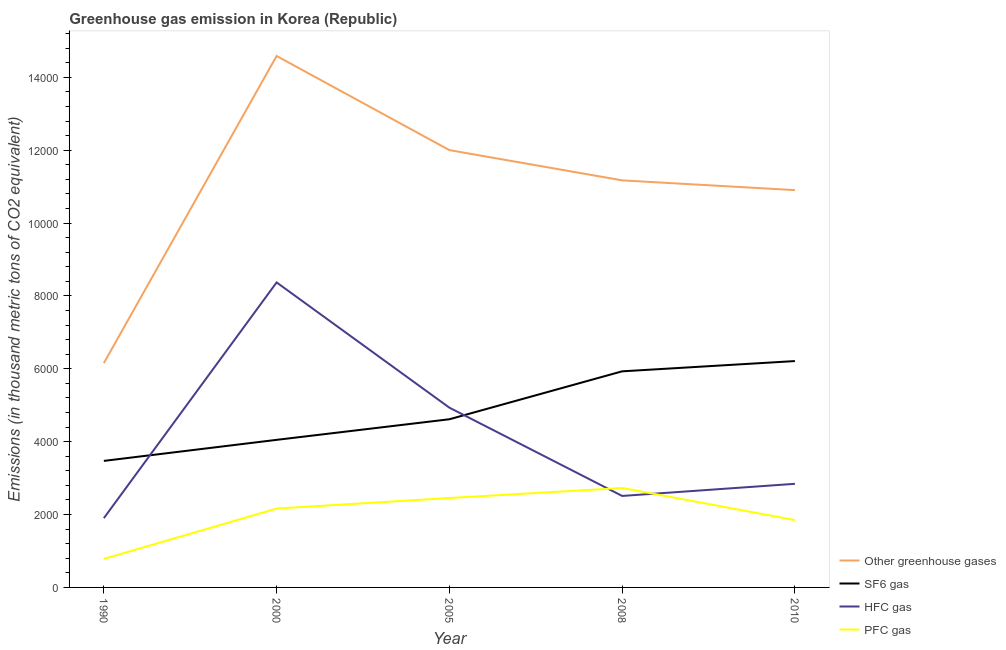Does the line corresponding to emission of pfc gas intersect with the line corresponding to emission of greenhouse gases?
Provide a short and direct response. No. Is the number of lines equal to the number of legend labels?
Offer a terse response. Yes. What is the emission of pfc gas in 2010?
Make the answer very short. 1848. Across all years, what is the maximum emission of sf6 gas?
Offer a very short reply. 6213. Across all years, what is the minimum emission of pfc gas?
Offer a terse response. 782.6. What is the total emission of hfc gas in the graph?
Provide a succinct answer. 2.06e+04. What is the difference between the emission of sf6 gas in 1990 and that in 2010?
Provide a succinct answer. -2740.1. What is the difference between the emission of pfc gas in 2000 and the emission of greenhouse gases in 2010?
Ensure brevity in your answer.  -8740.1. What is the average emission of sf6 gas per year?
Provide a succinct answer. 4856.74. In the year 2005, what is the difference between the emission of sf6 gas and emission of greenhouse gases?
Make the answer very short. -7387.6. What is the ratio of the emission of sf6 gas in 2000 to that in 2010?
Your response must be concise. 0.65. What is the difference between the highest and the second highest emission of greenhouse gases?
Offer a terse response. 2584. What is the difference between the highest and the lowest emission of hfc gas?
Provide a succinct answer. 6470.2. In how many years, is the emission of sf6 gas greater than the average emission of sf6 gas taken over all years?
Provide a succinct answer. 2. Is the sum of the emission of pfc gas in 2005 and 2010 greater than the maximum emission of hfc gas across all years?
Ensure brevity in your answer.  No. Is it the case that in every year, the sum of the emission of greenhouse gases and emission of sf6 gas is greater than the emission of hfc gas?
Offer a terse response. Yes. Does the emission of greenhouse gases monotonically increase over the years?
Keep it short and to the point. No. Is the emission of pfc gas strictly greater than the emission of hfc gas over the years?
Your answer should be compact. No. Is the emission of hfc gas strictly less than the emission of greenhouse gases over the years?
Offer a very short reply. Yes. How many lines are there?
Your response must be concise. 4. How many years are there in the graph?
Keep it short and to the point. 5. What is the difference between two consecutive major ticks on the Y-axis?
Offer a terse response. 2000. Does the graph contain any zero values?
Your response must be concise. No. Does the graph contain grids?
Provide a succinct answer. No. How many legend labels are there?
Make the answer very short. 4. How are the legend labels stacked?
Your answer should be very brief. Vertical. What is the title of the graph?
Your response must be concise. Greenhouse gas emission in Korea (Republic). What is the label or title of the Y-axis?
Offer a very short reply. Emissions (in thousand metric tons of CO2 equivalent). What is the Emissions (in thousand metric tons of CO2 equivalent) in Other greenhouse gases in 1990?
Offer a very short reply. 6157.2. What is the Emissions (in thousand metric tons of CO2 equivalent) of SF6 gas in 1990?
Ensure brevity in your answer.  3472.9. What is the Emissions (in thousand metric tons of CO2 equivalent) in HFC gas in 1990?
Offer a very short reply. 1901.7. What is the Emissions (in thousand metric tons of CO2 equivalent) of PFC gas in 1990?
Your answer should be very brief. 782.6. What is the Emissions (in thousand metric tons of CO2 equivalent) of Other greenhouse gases in 2000?
Keep it short and to the point. 1.46e+04. What is the Emissions (in thousand metric tons of CO2 equivalent) of SF6 gas in 2000?
Your answer should be compact. 4050.5. What is the Emissions (in thousand metric tons of CO2 equivalent) in HFC gas in 2000?
Keep it short and to the point. 8371.9. What is the Emissions (in thousand metric tons of CO2 equivalent) of PFC gas in 2000?
Provide a succinct answer. 2164.9. What is the Emissions (in thousand metric tons of CO2 equivalent) of Other greenhouse gases in 2005?
Offer a terse response. 1.20e+04. What is the Emissions (in thousand metric tons of CO2 equivalent) of SF6 gas in 2005?
Provide a succinct answer. 4615.7. What is the Emissions (in thousand metric tons of CO2 equivalent) in HFC gas in 2005?
Your response must be concise. 4933.9. What is the Emissions (in thousand metric tons of CO2 equivalent) of PFC gas in 2005?
Keep it short and to the point. 2453.7. What is the Emissions (in thousand metric tons of CO2 equivalent) in Other greenhouse gases in 2008?
Your answer should be compact. 1.12e+04. What is the Emissions (in thousand metric tons of CO2 equivalent) in SF6 gas in 2008?
Provide a short and direct response. 5931.6. What is the Emissions (in thousand metric tons of CO2 equivalent) in HFC gas in 2008?
Offer a very short reply. 2511.2. What is the Emissions (in thousand metric tons of CO2 equivalent) in PFC gas in 2008?
Ensure brevity in your answer.  2730.1. What is the Emissions (in thousand metric tons of CO2 equivalent) in Other greenhouse gases in 2010?
Offer a very short reply. 1.09e+04. What is the Emissions (in thousand metric tons of CO2 equivalent) in SF6 gas in 2010?
Offer a very short reply. 6213. What is the Emissions (in thousand metric tons of CO2 equivalent) of HFC gas in 2010?
Offer a terse response. 2844. What is the Emissions (in thousand metric tons of CO2 equivalent) of PFC gas in 2010?
Offer a very short reply. 1848. Across all years, what is the maximum Emissions (in thousand metric tons of CO2 equivalent) in Other greenhouse gases?
Provide a short and direct response. 1.46e+04. Across all years, what is the maximum Emissions (in thousand metric tons of CO2 equivalent) of SF6 gas?
Your answer should be compact. 6213. Across all years, what is the maximum Emissions (in thousand metric tons of CO2 equivalent) of HFC gas?
Give a very brief answer. 8371.9. Across all years, what is the maximum Emissions (in thousand metric tons of CO2 equivalent) of PFC gas?
Your answer should be very brief. 2730.1. Across all years, what is the minimum Emissions (in thousand metric tons of CO2 equivalent) in Other greenhouse gases?
Your answer should be compact. 6157.2. Across all years, what is the minimum Emissions (in thousand metric tons of CO2 equivalent) of SF6 gas?
Offer a very short reply. 3472.9. Across all years, what is the minimum Emissions (in thousand metric tons of CO2 equivalent) in HFC gas?
Offer a terse response. 1901.7. Across all years, what is the minimum Emissions (in thousand metric tons of CO2 equivalent) in PFC gas?
Offer a very short reply. 782.6. What is the total Emissions (in thousand metric tons of CO2 equivalent) of Other greenhouse gases in the graph?
Offer a terse response. 5.48e+04. What is the total Emissions (in thousand metric tons of CO2 equivalent) in SF6 gas in the graph?
Provide a short and direct response. 2.43e+04. What is the total Emissions (in thousand metric tons of CO2 equivalent) in HFC gas in the graph?
Give a very brief answer. 2.06e+04. What is the total Emissions (in thousand metric tons of CO2 equivalent) of PFC gas in the graph?
Your answer should be very brief. 9979.3. What is the difference between the Emissions (in thousand metric tons of CO2 equivalent) of Other greenhouse gases in 1990 and that in 2000?
Keep it short and to the point. -8430.1. What is the difference between the Emissions (in thousand metric tons of CO2 equivalent) in SF6 gas in 1990 and that in 2000?
Your answer should be compact. -577.6. What is the difference between the Emissions (in thousand metric tons of CO2 equivalent) in HFC gas in 1990 and that in 2000?
Your response must be concise. -6470.2. What is the difference between the Emissions (in thousand metric tons of CO2 equivalent) in PFC gas in 1990 and that in 2000?
Offer a terse response. -1382.3. What is the difference between the Emissions (in thousand metric tons of CO2 equivalent) in Other greenhouse gases in 1990 and that in 2005?
Your response must be concise. -5846.1. What is the difference between the Emissions (in thousand metric tons of CO2 equivalent) of SF6 gas in 1990 and that in 2005?
Give a very brief answer. -1142.8. What is the difference between the Emissions (in thousand metric tons of CO2 equivalent) in HFC gas in 1990 and that in 2005?
Offer a terse response. -3032.2. What is the difference between the Emissions (in thousand metric tons of CO2 equivalent) in PFC gas in 1990 and that in 2005?
Provide a succinct answer. -1671.1. What is the difference between the Emissions (in thousand metric tons of CO2 equivalent) of Other greenhouse gases in 1990 and that in 2008?
Your answer should be compact. -5015.7. What is the difference between the Emissions (in thousand metric tons of CO2 equivalent) in SF6 gas in 1990 and that in 2008?
Your response must be concise. -2458.7. What is the difference between the Emissions (in thousand metric tons of CO2 equivalent) in HFC gas in 1990 and that in 2008?
Provide a succinct answer. -609.5. What is the difference between the Emissions (in thousand metric tons of CO2 equivalent) of PFC gas in 1990 and that in 2008?
Provide a succinct answer. -1947.5. What is the difference between the Emissions (in thousand metric tons of CO2 equivalent) of Other greenhouse gases in 1990 and that in 2010?
Offer a very short reply. -4747.8. What is the difference between the Emissions (in thousand metric tons of CO2 equivalent) in SF6 gas in 1990 and that in 2010?
Make the answer very short. -2740.1. What is the difference between the Emissions (in thousand metric tons of CO2 equivalent) in HFC gas in 1990 and that in 2010?
Your answer should be very brief. -942.3. What is the difference between the Emissions (in thousand metric tons of CO2 equivalent) of PFC gas in 1990 and that in 2010?
Offer a terse response. -1065.4. What is the difference between the Emissions (in thousand metric tons of CO2 equivalent) in Other greenhouse gases in 2000 and that in 2005?
Offer a very short reply. 2584. What is the difference between the Emissions (in thousand metric tons of CO2 equivalent) in SF6 gas in 2000 and that in 2005?
Offer a very short reply. -565.2. What is the difference between the Emissions (in thousand metric tons of CO2 equivalent) of HFC gas in 2000 and that in 2005?
Ensure brevity in your answer.  3438. What is the difference between the Emissions (in thousand metric tons of CO2 equivalent) in PFC gas in 2000 and that in 2005?
Your response must be concise. -288.8. What is the difference between the Emissions (in thousand metric tons of CO2 equivalent) of Other greenhouse gases in 2000 and that in 2008?
Offer a very short reply. 3414.4. What is the difference between the Emissions (in thousand metric tons of CO2 equivalent) of SF6 gas in 2000 and that in 2008?
Ensure brevity in your answer.  -1881.1. What is the difference between the Emissions (in thousand metric tons of CO2 equivalent) in HFC gas in 2000 and that in 2008?
Make the answer very short. 5860.7. What is the difference between the Emissions (in thousand metric tons of CO2 equivalent) in PFC gas in 2000 and that in 2008?
Your answer should be very brief. -565.2. What is the difference between the Emissions (in thousand metric tons of CO2 equivalent) in Other greenhouse gases in 2000 and that in 2010?
Offer a terse response. 3682.3. What is the difference between the Emissions (in thousand metric tons of CO2 equivalent) in SF6 gas in 2000 and that in 2010?
Your answer should be compact. -2162.5. What is the difference between the Emissions (in thousand metric tons of CO2 equivalent) of HFC gas in 2000 and that in 2010?
Keep it short and to the point. 5527.9. What is the difference between the Emissions (in thousand metric tons of CO2 equivalent) in PFC gas in 2000 and that in 2010?
Your response must be concise. 316.9. What is the difference between the Emissions (in thousand metric tons of CO2 equivalent) in Other greenhouse gases in 2005 and that in 2008?
Ensure brevity in your answer.  830.4. What is the difference between the Emissions (in thousand metric tons of CO2 equivalent) in SF6 gas in 2005 and that in 2008?
Provide a succinct answer. -1315.9. What is the difference between the Emissions (in thousand metric tons of CO2 equivalent) of HFC gas in 2005 and that in 2008?
Your answer should be very brief. 2422.7. What is the difference between the Emissions (in thousand metric tons of CO2 equivalent) in PFC gas in 2005 and that in 2008?
Provide a succinct answer. -276.4. What is the difference between the Emissions (in thousand metric tons of CO2 equivalent) in Other greenhouse gases in 2005 and that in 2010?
Provide a succinct answer. 1098.3. What is the difference between the Emissions (in thousand metric tons of CO2 equivalent) in SF6 gas in 2005 and that in 2010?
Offer a terse response. -1597.3. What is the difference between the Emissions (in thousand metric tons of CO2 equivalent) in HFC gas in 2005 and that in 2010?
Your answer should be compact. 2089.9. What is the difference between the Emissions (in thousand metric tons of CO2 equivalent) in PFC gas in 2005 and that in 2010?
Keep it short and to the point. 605.7. What is the difference between the Emissions (in thousand metric tons of CO2 equivalent) in Other greenhouse gases in 2008 and that in 2010?
Give a very brief answer. 267.9. What is the difference between the Emissions (in thousand metric tons of CO2 equivalent) in SF6 gas in 2008 and that in 2010?
Your response must be concise. -281.4. What is the difference between the Emissions (in thousand metric tons of CO2 equivalent) in HFC gas in 2008 and that in 2010?
Give a very brief answer. -332.8. What is the difference between the Emissions (in thousand metric tons of CO2 equivalent) in PFC gas in 2008 and that in 2010?
Make the answer very short. 882.1. What is the difference between the Emissions (in thousand metric tons of CO2 equivalent) in Other greenhouse gases in 1990 and the Emissions (in thousand metric tons of CO2 equivalent) in SF6 gas in 2000?
Offer a very short reply. 2106.7. What is the difference between the Emissions (in thousand metric tons of CO2 equivalent) of Other greenhouse gases in 1990 and the Emissions (in thousand metric tons of CO2 equivalent) of HFC gas in 2000?
Make the answer very short. -2214.7. What is the difference between the Emissions (in thousand metric tons of CO2 equivalent) in Other greenhouse gases in 1990 and the Emissions (in thousand metric tons of CO2 equivalent) in PFC gas in 2000?
Provide a succinct answer. 3992.3. What is the difference between the Emissions (in thousand metric tons of CO2 equivalent) of SF6 gas in 1990 and the Emissions (in thousand metric tons of CO2 equivalent) of HFC gas in 2000?
Provide a short and direct response. -4899. What is the difference between the Emissions (in thousand metric tons of CO2 equivalent) in SF6 gas in 1990 and the Emissions (in thousand metric tons of CO2 equivalent) in PFC gas in 2000?
Keep it short and to the point. 1308. What is the difference between the Emissions (in thousand metric tons of CO2 equivalent) of HFC gas in 1990 and the Emissions (in thousand metric tons of CO2 equivalent) of PFC gas in 2000?
Provide a short and direct response. -263.2. What is the difference between the Emissions (in thousand metric tons of CO2 equivalent) in Other greenhouse gases in 1990 and the Emissions (in thousand metric tons of CO2 equivalent) in SF6 gas in 2005?
Offer a very short reply. 1541.5. What is the difference between the Emissions (in thousand metric tons of CO2 equivalent) in Other greenhouse gases in 1990 and the Emissions (in thousand metric tons of CO2 equivalent) in HFC gas in 2005?
Keep it short and to the point. 1223.3. What is the difference between the Emissions (in thousand metric tons of CO2 equivalent) of Other greenhouse gases in 1990 and the Emissions (in thousand metric tons of CO2 equivalent) of PFC gas in 2005?
Ensure brevity in your answer.  3703.5. What is the difference between the Emissions (in thousand metric tons of CO2 equivalent) in SF6 gas in 1990 and the Emissions (in thousand metric tons of CO2 equivalent) in HFC gas in 2005?
Give a very brief answer. -1461. What is the difference between the Emissions (in thousand metric tons of CO2 equivalent) in SF6 gas in 1990 and the Emissions (in thousand metric tons of CO2 equivalent) in PFC gas in 2005?
Your answer should be very brief. 1019.2. What is the difference between the Emissions (in thousand metric tons of CO2 equivalent) in HFC gas in 1990 and the Emissions (in thousand metric tons of CO2 equivalent) in PFC gas in 2005?
Provide a short and direct response. -552. What is the difference between the Emissions (in thousand metric tons of CO2 equivalent) of Other greenhouse gases in 1990 and the Emissions (in thousand metric tons of CO2 equivalent) of SF6 gas in 2008?
Offer a terse response. 225.6. What is the difference between the Emissions (in thousand metric tons of CO2 equivalent) in Other greenhouse gases in 1990 and the Emissions (in thousand metric tons of CO2 equivalent) in HFC gas in 2008?
Ensure brevity in your answer.  3646. What is the difference between the Emissions (in thousand metric tons of CO2 equivalent) of Other greenhouse gases in 1990 and the Emissions (in thousand metric tons of CO2 equivalent) of PFC gas in 2008?
Your answer should be very brief. 3427.1. What is the difference between the Emissions (in thousand metric tons of CO2 equivalent) in SF6 gas in 1990 and the Emissions (in thousand metric tons of CO2 equivalent) in HFC gas in 2008?
Your answer should be compact. 961.7. What is the difference between the Emissions (in thousand metric tons of CO2 equivalent) of SF6 gas in 1990 and the Emissions (in thousand metric tons of CO2 equivalent) of PFC gas in 2008?
Offer a terse response. 742.8. What is the difference between the Emissions (in thousand metric tons of CO2 equivalent) in HFC gas in 1990 and the Emissions (in thousand metric tons of CO2 equivalent) in PFC gas in 2008?
Make the answer very short. -828.4. What is the difference between the Emissions (in thousand metric tons of CO2 equivalent) of Other greenhouse gases in 1990 and the Emissions (in thousand metric tons of CO2 equivalent) of SF6 gas in 2010?
Offer a terse response. -55.8. What is the difference between the Emissions (in thousand metric tons of CO2 equivalent) in Other greenhouse gases in 1990 and the Emissions (in thousand metric tons of CO2 equivalent) in HFC gas in 2010?
Ensure brevity in your answer.  3313.2. What is the difference between the Emissions (in thousand metric tons of CO2 equivalent) of Other greenhouse gases in 1990 and the Emissions (in thousand metric tons of CO2 equivalent) of PFC gas in 2010?
Offer a terse response. 4309.2. What is the difference between the Emissions (in thousand metric tons of CO2 equivalent) in SF6 gas in 1990 and the Emissions (in thousand metric tons of CO2 equivalent) in HFC gas in 2010?
Your response must be concise. 628.9. What is the difference between the Emissions (in thousand metric tons of CO2 equivalent) of SF6 gas in 1990 and the Emissions (in thousand metric tons of CO2 equivalent) of PFC gas in 2010?
Offer a very short reply. 1624.9. What is the difference between the Emissions (in thousand metric tons of CO2 equivalent) in HFC gas in 1990 and the Emissions (in thousand metric tons of CO2 equivalent) in PFC gas in 2010?
Provide a short and direct response. 53.7. What is the difference between the Emissions (in thousand metric tons of CO2 equivalent) in Other greenhouse gases in 2000 and the Emissions (in thousand metric tons of CO2 equivalent) in SF6 gas in 2005?
Make the answer very short. 9971.6. What is the difference between the Emissions (in thousand metric tons of CO2 equivalent) in Other greenhouse gases in 2000 and the Emissions (in thousand metric tons of CO2 equivalent) in HFC gas in 2005?
Your response must be concise. 9653.4. What is the difference between the Emissions (in thousand metric tons of CO2 equivalent) of Other greenhouse gases in 2000 and the Emissions (in thousand metric tons of CO2 equivalent) of PFC gas in 2005?
Provide a short and direct response. 1.21e+04. What is the difference between the Emissions (in thousand metric tons of CO2 equivalent) in SF6 gas in 2000 and the Emissions (in thousand metric tons of CO2 equivalent) in HFC gas in 2005?
Your answer should be compact. -883.4. What is the difference between the Emissions (in thousand metric tons of CO2 equivalent) of SF6 gas in 2000 and the Emissions (in thousand metric tons of CO2 equivalent) of PFC gas in 2005?
Offer a very short reply. 1596.8. What is the difference between the Emissions (in thousand metric tons of CO2 equivalent) of HFC gas in 2000 and the Emissions (in thousand metric tons of CO2 equivalent) of PFC gas in 2005?
Your answer should be compact. 5918.2. What is the difference between the Emissions (in thousand metric tons of CO2 equivalent) of Other greenhouse gases in 2000 and the Emissions (in thousand metric tons of CO2 equivalent) of SF6 gas in 2008?
Provide a succinct answer. 8655.7. What is the difference between the Emissions (in thousand metric tons of CO2 equivalent) in Other greenhouse gases in 2000 and the Emissions (in thousand metric tons of CO2 equivalent) in HFC gas in 2008?
Ensure brevity in your answer.  1.21e+04. What is the difference between the Emissions (in thousand metric tons of CO2 equivalent) in Other greenhouse gases in 2000 and the Emissions (in thousand metric tons of CO2 equivalent) in PFC gas in 2008?
Provide a succinct answer. 1.19e+04. What is the difference between the Emissions (in thousand metric tons of CO2 equivalent) of SF6 gas in 2000 and the Emissions (in thousand metric tons of CO2 equivalent) of HFC gas in 2008?
Give a very brief answer. 1539.3. What is the difference between the Emissions (in thousand metric tons of CO2 equivalent) of SF6 gas in 2000 and the Emissions (in thousand metric tons of CO2 equivalent) of PFC gas in 2008?
Provide a succinct answer. 1320.4. What is the difference between the Emissions (in thousand metric tons of CO2 equivalent) in HFC gas in 2000 and the Emissions (in thousand metric tons of CO2 equivalent) in PFC gas in 2008?
Offer a very short reply. 5641.8. What is the difference between the Emissions (in thousand metric tons of CO2 equivalent) of Other greenhouse gases in 2000 and the Emissions (in thousand metric tons of CO2 equivalent) of SF6 gas in 2010?
Keep it short and to the point. 8374.3. What is the difference between the Emissions (in thousand metric tons of CO2 equivalent) of Other greenhouse gases in 2000 and the Emissions (in thousand metric tons of CO2 equivalent) of HFC gas in 2010?
Give a very brief answer. 1.17e+04. What is the difference between the Emissions (in thousand metric tons of CO2 equivalent) of Other greenhouse gases in 2000 and the Emissions (in thousand metric tons of CO2 equivalent) of PFC gas in 2010?
Offer a very short reply. 1.27e+04. What is the difference between the Emissions (in thousand metric tons of CO2 equivalent) of SF6 gas in 2000 and the Emissions (in thousand metric tons of CO2 equivalent) of HFC gas in 2010?
Offer a very short reply. 1206.5. What is the difference between the Emissions (in thousand metric tons of CO2 equivalent) of SF6 gas in 2000 and the Emissions (in thousand metric tons of CO2 equivalent) of PFC gas in 2010?
Your response must be concise. 2202.5. What is the difference between the Emissions (in thousand metric tons of CO2 equivalent) in HFC gas in 2000 and the Emissions (in thousand metric tons of CO2 equivalent) in PFC gas in 2010?
Offer a very short reply. 6523.9. What is the difference between the Emissions (in thousand metric tons of CO2 equivalent) in Other greenhouse gases in 2005 and the Emissions (in thousand metric tons of CO2 equivalent) in SF6 gas in 2008?
Ensure brevity in your answer.  6071.7. What is the difference between the Emissions (in thousand metric tons of CO2 equivalent) of Other greenhouse gases in 2005 and the Emissions (in thousand metric tons of CO2 equivalent) of HFC gas in 2008?
Keep it short and to the point. 9492.1. What is the difference between the Emissions (in thousand metric tons of CO2 equivalent) of Other greenhouse gases in 2005 and the Emissions (in thousand metric tons of CO2 equivalent) of PFC gas in 2008?
Offer a very short reply. 9273.2. What is the difference between the Emissions (in thousand metric tons of CO2 equivalent) of SF6 gas in 2005 and the Emissions (in thousand metric tons of CO2 equivalent) of HFC gas in 2008?
Ensure brevity in your answer.  2104.5. What is the difference between the Emissions (in thousand metric tons of CO2 equivalent) of SF6 gas in 2005 and the Emissions (in thousand metric tons of CO2 equivalent) of PFC gas in 2008?
Offer a terse response. 1885.6. What is the difference between the Emissions (in thousand metric tons of CO2 equivalent) of HFC gas in 2005 and the Emissions (in thousand metric tons of CO2 equivalent) of PFC gas in 2008?
Give a very brief answer. 2203.8. What is the difference between the Emissions (in thousand metric tons of CO2 equivalent) of Other greenhouse gases in 2005 and the Emissions (in thousand metric tons of CO2 equivalent) of SF6 gas in 2010?
Offer a terse response. 5790.3. What is the difference between the Emissions (in thousand metric tons of CO2 equivalent) of Other greenhouse gases in 2005 and the Emissions (in thousand metric tons of CO2 equivalent) of HFC gas in 2010?
Provide a succinct answer. 9159.3. What is the difference between the Emissions (in thousand metric tons of CO2 equivalent) in Other greenhouse gases in 2005 and the Emissions (in thousand metric tons of CO2 equivalent) in PFC gas in 2010?
Your response must be concise. 1.02e+04. What is the difference between the Emissions (in thousand metric tons of CO2 equivalent) in SF6 gas in 2005 and the Emissions (in thousand metric tons of CO2 equivalent) in HFC gas in 2010?
Ensure brevity in your answer.  1771.7. What is the difference between the Emissions (in thousand metric tons of CO2 equivalent) in SF6 gas in 2005 and the Emissions (in thousand metric tons of CO2 equivalent) in PFC gas in 2010?
Ensure brevity in your answer.  2767.7. What is the difference between the Emissions (in thousand metric tons of CO2 equivalent) of HFC gas in 2005 and the Emissions (in thousand metric tons of CO2 equivalent) of PFC gas in 2010?
Ensure brevity in your answer.  3085.9. What is the difference between the Emissions (in thousand metric tons of CO2 equivalent) in Other greenhouse gases in 2008 and the Emissions (in thousand metric tons of CO2 equivalent) in SF6 gas in 2010?
Offer a terse response. 4959.9. What is the difference between the Emissions (in thousand metric tons of CO2 equivalent) of Other greenhouse gases in 2008 and the Emissions (in thousand metric tons of CO2 equivalent) of HFC gas in 2010?
Your answer should be compact. 8328.9. What is the difference between the Emissions (in thousand metric tons of CO2 equivalent) of Other greenhouse gases in 2008 and the Emissions (in thousand metric tons of CO2 equivalent) of PFC gas in 2010?
Provide a succinct answer. 9324.9. What is the difference between the Emissions (in thousand metric tons of CO2 equivalent) of SF6 gas in 2008 and the Emissions (in thousand metric tons of CO2 equivalent) of HFC gas in 2010?
Provide a short and direct response. 3087.6. What is the difference between the Emissions (in thousand metric tons of CO2 equivalent) of SF6 gas in 2008 and the Emissions (in thousand metric tons of CO2 equivalent) of PFC gas in 2010?
Offer a terse response. 4083.6. What is the difference between the Emissions (in thousand metric tons of CO2 equivalent) of HFC gas in 2008 and the Emissions (in thousand metric tons of CO2 equivalent) of PFC gas in 2010?
Your answer should be very brief. 663.2. What is the average Emissions (in thousand metric tons of CO2 equivalent) of Other greenhouse gases per year?
Ensure brevity in your answer.  1.10e+04. What is the average Emissions (in thousand metric tons of CO2 equivalent) of SF6 gas per year?
Ensure brevity in your answer.  4856.74. What is the average Emissions (in thousand metric tons of CO2 equivalent) in HFC gas per year?
Provide a succinct answer. 4112.54. What is the average Emissions (in thousand metric tons of CO2 equivalent) in PFC gas per year?
Ensure brevity in your answer.  1995.86. In the year 1990, what is the difference between the Emissions (in thousand metric tons of CO2 equivalent) of Other greenhouse gases and Emissions (in thousand metric tons of CO2 equivalent) of SF6 gas?
Make the answer very short. 2684.3. In the year 1990, what is the difference between the Emissions (in thousand metric tons of CO2 equivalent) in Other greenhouse gases and Emissions (in thousand metric tons of CO2 equivalent) in HFC gas?
Offer a terse response. 4255.5. In the year 1990, what is the difference between the Emissions (in thousand metric tons of CO2 equivalent) in Other greenhouse gases and Emissions (in thousand metric tons of CO2 equivalent) in PFC gas?
Provide a short and direct response. 5374.6. In the year 1990, what is the difference between the Emissions (in thousand metric tons of CO2 equivalent) of SF6 gas and Emissions (in thousand metric tons of CO2 equivalent) of HFC gas?
Your response must be concise. 1571.2. In the year 1990, what is the difference between the Emissions (in thousand metric tons of CO2 equivalent) of SF6 gas and Emissions (in thousand metric tons of CO2 equivalent) of PFC gas?
Make the answer very short. 2690.3. In the year 1990, what is the difference between the Emissions (in thousand metric tons of CO2 equivalent) in HFC gas and Emissions (in thousand metric tons of CO2 equivalent) in PFC gas?
Your answer should be very brief. 1119.1. In the year 2000, what is the difference between the Emissions (in thousand metric tons of CO2 equivalent) in Other greenhouse gases and Emissions (in thousand metric tons of CO2 equivalent) in SF6 gas?
Provide a succinct answer. 1.05e+04. In the year 2000, what is the difference between the Emissions (in thousand metric tons of CO2 equivalent) of Other greenhouse gases and Emissions (in thousand metric tons of CO2 equivalent) of HFC gas?
Make the answer very short. 6215.4. In the year 2000, what is the difference between the Emissions (in thousand metric tons of CO2 equivalent) in Other greenhouse gases and Emissions (in thousand metric tons of CO2 equivalent) in PFC gas?
Keep it short and to the point. 1.24e+04. In the year 2000, what is the difference between the Emissions (in thousand metric tons of CO2 equivalent) in SF6 gas and Emissions (in thousand metric tons of CO2 equivalent) in HFC gas?
Your answer should be very brief. -4321.4. In the year 2000, what is the difference between the Emissions (in thousand metric tons of CO2 equivalent) in SF6 gas and Emissions (in thousand metric tons of CO2 equivalent) in PFC gas?
Your answer should be very brief. 1885.6. In the year 2000, what is the difference between the Emissions (in thousand metric tons of CO2 equivalent) of HFC gas and Emissions (in thousand metric tons of CO2 equivalent) of PFC gas?
Your answer should be very brief. 6207. In the year 2005, what is the difference between the Emissions (in thousand metric tons of CO2 equivalent) of Other greenhouse gases and Emissions (in thousand metric tons of CO2 equivalent) of SF6 gas?
Offer a very short reply. 7387.6. In the year 2005, what is the difference between the Emissions (in thousand metric tons of CO2 equivalent) of Other greenhouse gases and Emissions (in thousand metric tons of CO2 equivalent) of HFC gas?
Your answer should be compact. 7069.4. In the year 2005, what is the difference between the Emissions (in thousand metric tons of CO2 equivalent) of Other greenhouse gases and Emissions (in thousand metric tons of CO2 equivalent) of PFC gas?
Provide a short and direct response. 9549.6. In the year 2005, what is the difference between the Emissions (in thousand metric tons of CO2 equivalent) of SF6 gas and Emissions (in thousand metric tons of CO2 equivalent) of HFC gas?
Give a very brief answer. -318.2. In the year 2005, what is the difference between the Emissions (in thousand metric tons of CO2 equivalent) of SF6 gas and Emissions (in thousand metric tons of CO2 equivalent) of PFC gas?
Keep it short and to the point. 2162. In the year 2005, what is the difference between the Emissions (in thousand metric tons of CO2 equivalent) in HFC gas and Emissions (in thousand metric tons of CO2 equivalent) in PFC gas?
Keep it short and to the point. 2480.2. In the year 2008, what is the difference between the Emissions (in thousand metric tons of CO2 equivalent) of Other greenhouse gases and Emissions (in thousand metric tons of CO2 equivalent) of SF6 gas?
Your answer should be compact. 5241.3. In the year 2008, what is the difference between the Emissions (in thousand metric tons of CO2 equivalent) of Other greenhouse gases and Emissions (in thousand metric tons of CO2 equivalent) of HFC gas?
Give a very brief answer. 8661.7. In the year 2008, what is the difference between the Emissions (in thousand metric tons of CO2 equivalent) in Other greenhouse gases and Emissions (in thousand metric tons of CO2 equivalent) in PFC gas?
Provide a succinct answer. 8442.8. In the year 2008, what is the difference between the Emissions (in thousand metric tons of CO2 equivalent) in SF6 gas and Emissions (in thousand metric tons of CO2 equivalent) in HFC gas?
Your answer should be compact. 3420.4. In the year 2008, what is the difference between the Emissions (in thousand metric tons of CO2 equivalent) in SF6 gas and Emissions (in thousand metric tons of CO2 equivalent) in PFC gas?
Your answer should be compact. 3201.5. In the year 2008, what is the difference between the Emissions (in thousand metric tons of CO2 equivalent) of HFC gas and Emissions (in thousand metric tons of CO2 equivalent) of PFC gas?
Your response must be concise. -218.9. In the year 2010, what is the difference between the Emissions (in thousand metric tons of CO2 equivalent) of Other greenhouse gases and Emissions (in thousand metric tons of CO2 equivalent) of SF6 gas?
Provide a succinct answer. 4692. In the year 2010, what is the difference between the Emissions (in thousand metric tons of CO2 equivalent) in Other greenhouse gases and Emissions (in thousand metric tons of CO2 equivalent) in HFC gas?
Offer a very short reply. 8061. In the year 2010, what is the difference between the Emissions (in thousand metric tons of CO2 equivalent) of Other greenhouse gases and Emissions (in thousand metric tons of CO2 equivalent) of PFC gas?
Provide a succinct answer. 9057. In the year 2010, what is the difference between the Emissions (in thousand metric tons of CO2 equivalent) in SF6 gas and Emissions (in thousand metric tons of CO2 equivalent) in HFC gas?
Your response must be concise. 3369. In the year 2010, what is the difference between the Emissions (in thousand metric tons of CO2 equivalent) of SF6 gas and Emissions (in thousand metric tons of CO2 equivalent) of PFC gas?
Make the answer very short. 4365. In the year 2010, what is the difference between the Emissions (in thousand metric tons of CO2 equivalent) of HFC gas and Emissions (in thousand metric tons of CO2 equivalent) of PFC gas?
Your response must be concise. 996. What is the ratio of the Emissions (in thousand metric tons of CO2 equivalent) in Other greenhouse gases in 1990 to that in 2000?
Your answer should be compact. 0.42. What is the ratio of the Emissions (in thousand metric tons of CO2 equivalent) of SF6 gas in 1990 to that in 2000?
Your answer should be very brief. 0.86. What is the ratio of the Emissions (in thousand metric tons of CO2 equivalent) in HFC gas in 1990 to that in 2000?
Your answer should be very brief. 0.23. What is the ratio of the Emissions (in thousand metric tons of CO2 equivalent) in PFC gas in 1990 to that in 2000?
Provide a short and direct response. 0.36. What is the ratio of the Emissions (in thousand metric tons of CO2 equivalent) of Other greenhouse gases in 1990 to that in 2005?
Provide a short and direct response. 0.51. What is the ratio of the Emissions (in thousand metric tons of CO2 equivalent) of SF6 gas in 1990 to that in 2005?
Offer a terse response. 0.75. What is the ratio of the Emissions (in thousand metric tons of CO2 equivalent) in HFC gas in 1990 to that in 2005?
Your answer should be very brief. 0.39. What is the ratio of the Emissions (in thousand metric tons of CO2 equivalent) of PFC gas in 1990 to that in 2005?
Make the answer very short. 0.32. What is the ratio of the Emissions (in thousand metric tons of CO2 equivalent) in Other greenhouse gases in 1990 to that in 2008?
Your response must be concise. 0.55. What is the ratio of the Emissions (in thousand metric tons of CO2 equivalent) in SF6 gas in 1990 to that in 2008?
Give a very brief answer. 0.59. What is the ratio of the Emissions (in thousand metric tons of CO2 equivalent) in HFC gas in 1990 to that in 2008?
Your answer should be compact. 0.76. What is the ratio of the Emissions (in thousand metric tons of CO2 equivalent) in PFC gas in 1990 to that in 2008?
Ensure brevity in your answer.  0.29. What is the ratio of the Emissions (in thousand metric tons of CO2 equivalent) in Other greenhouse gases in 1990 to that in 2010?
Your answer should be compact. 0.56. What is the ratio of the Emissions (in thousand metric tons of CO2 equivalent) in SF6 gas in 1990 to that in 2010?
Your answer should be very brief. 0.56. What is the ratio of the Emissions (in thousand metric tons of CO2 equivalent) in HFC gas in 1990 to that in 2010?
Your answer should be compact. 0.67. What is the ratio of the Emissions (in thousand metric tons of CO2 equivalent) of PFC gas in 1990 to that in 2010?
Your response must be concise. 0.42. What is the ratio of the Emissions (in thousand metric tons of CO2 equivalent) in Other greenhouse gases in 2000 to that in 2005?
Provide a succinct answer. 1.22. What is the ratio of the Emissions (in thousand metric tons of CO2 equivalent) of SF6 gas in 2000 to that in 2005?
Provide a succinct answer. 0.88. What is the ratio of the Emissions (in thousand metric tons of CO2 equivalent) of HFC gas in 2000 to that in 2005?
Make the answer very short. 1.7. What is the ratio of the Emissions (in thousand metric tons of CO2 equivalent) in PFC gas in 2000 to that in 2005?
Give a very brief answer. 0.88. What is the ratio of the Emissions (in thousand metric tons of CO2 equivalent) in Other greenhouse gases in 2000 to that in 2008?
Your answer should be very brief. 1.31. What is the ratio of the Emissions (in thousand metric tons of CO2 equivalent) in SF6 gas in 2000 to that in 2008?
Offer a terse response. 0.68. What is the ratio of the Emissions (in thousand metric tons of CO2 equivalent) of HFC gas in 2000 to that in 2008?
Your answer should be very brief. 3.33. What is the ratio of the Emissions (in thousand metric tons of CO2 equivalent) of PFC gas in 2000 to that in 2008?
Ensure brevity in your answer.  0.79. What is the ratio of the Emissions (in thousand metric tons of CO2 equivalent) of Other greenhouse gases in 2000 to that in 2010?
Provide a succinct answer. 1.34. What is the ratio of the Emissions (in thousand metric tons of CO2 equivalent) in SF6 gas in 2000 to that in 2010?
Your response must be concise. 0.65. What is the ratio of the Emissions (in thousand metric tons of CO2 equivalent) in HFC gas in 2000 to that in 2010?
Your answer should be very brief. 2.94. What is the ratio of the Emissions (in thousand metric tons of CO2 equivalent) in PFC gas in 2000 to that in 2010?
Make the answer very short. 1.17. What is the ratio of the Emissions (in thousand metric tons of CO2 equivalent) of Other greenhouse gases in 2005 to that in 2008?
Your answer should be very brief. 1.07. What is the ratio of the Emissions (in thousand metric tons of CO2 equivalent) in SF6 gas in 2005 to that in 2008?
Give a very brief answer. 0.78. What is the ratio of the Emissions (in thousand metric tons of CO2 equivalent) of HFC gas in 2005 to that in 2008?
Your answer should be very brief. 1.96. What is the ratio of the Emissions (in thousand metric tons of CO2 equivalent) of PFC gas in 2005 to that in 2008?
Your answer should be very brief. 0.9. What is the ratio of the Emissions (in thousand metric tons of CO2 equivalent) in Other greenhouse gases in 2005 to that in 2010?
Offer a very short reply. 1.1. What is the ratio of the Emissions (in thousand metric tons of CO2 equivalent) of SF6 gas in 2005 to that in 2010?
Offer a terse response. 0.74. What is the ratio of the Emissions (in thousand metric tons of CO2 equivalent) in HFC gas in 2005 to that in 2010?
Your response must be concise. 1.73. What is the ratio of the Emissions (in thousand metric tons of CO2 equivalent) in PFC gas in 2005 to that in 2010?
Offer a terse response. 1.33. What is the ratio of the Emissions (in thousand metric tons of CO2 equivalent) in Other greenhouse gases in 2008 to that in 2010?
Your response must be concise. 1.02. What is the ratio of the Emissions (in thousand metric tons of CO2 equivalent) of SF6 gas in 2008 to that in 2010?
Your response must be concise. 0.95. What is the ratio of the Emissions (in thousand metric tons of CO2 equivalent) in HFC gas in 2008 to that in 2010?
Offer a terse response. 0.88. What is the ratio of the Emissions (in thousand metric tons of CO2 equivalent) of PFC gas in 2008 to that in 2010?
Give a very brief answer. 1.48. What is the difference between the highest and the second highest Emissions (in thousand metric tons of CO2 equivalent) of Other greenhouse gases?
Offer a terse response. 2584. What is the difference between the highest and the second highest Emissions (in thousand metric tons of CO2 equivalent) in SF6 gas?
Provide a succinct answer. 281.4. What is the difference between the highest and the second highest Emissions (in thousand metric tons of CO2 equivalent) in HFC gas?
Your answer should be very brief. 3438. What is the difference between the highest and the second highest Emissions (in thousand metric tons of CO2 equivalent) in PFC gas?
Your response must be concise. 276.4. What is the difference between the highest and the lowest Emissions (in thousand metric tons of CO2 equivalent) of Other greenhouse gases?
Provide a succinct answer. 8430.1. What is the difference between the highest and the lowest Emissions (in thousand metric tons of CO2 equivalent) of SF6 gas?
Ensure brevity in your answer.  2740.1. What is the difference between the highest and the lowest Emissions (in thousand metric tons of CO2 equivalent) in HFC gas?
Make the answer very short. 6470.2. What is the difference between the highest and the lowest Emissions (in thousand metric tons of CO2 equivalent) in PFC gas?
Make the answer very short. 1947.5. 